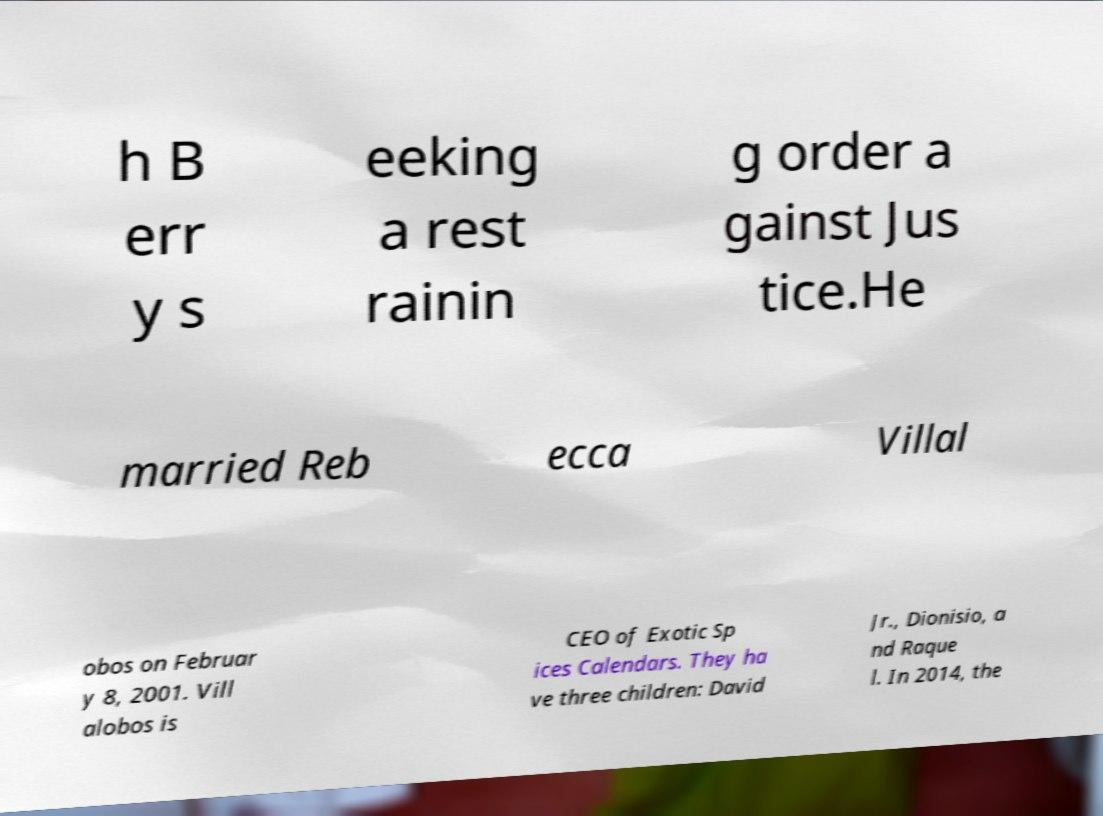Please identify and transcribe the text found in this image. h B err y s eeking a rest rainin g order a gainst Jus tice.He married Reb ecca Villal obos on Februar y 8, 2001. Vill alobos is CEO of Exotic Sp ices Calendars. They ha ve three children: David Jr., Dionisio, a nd Raque l. In 2014, the 